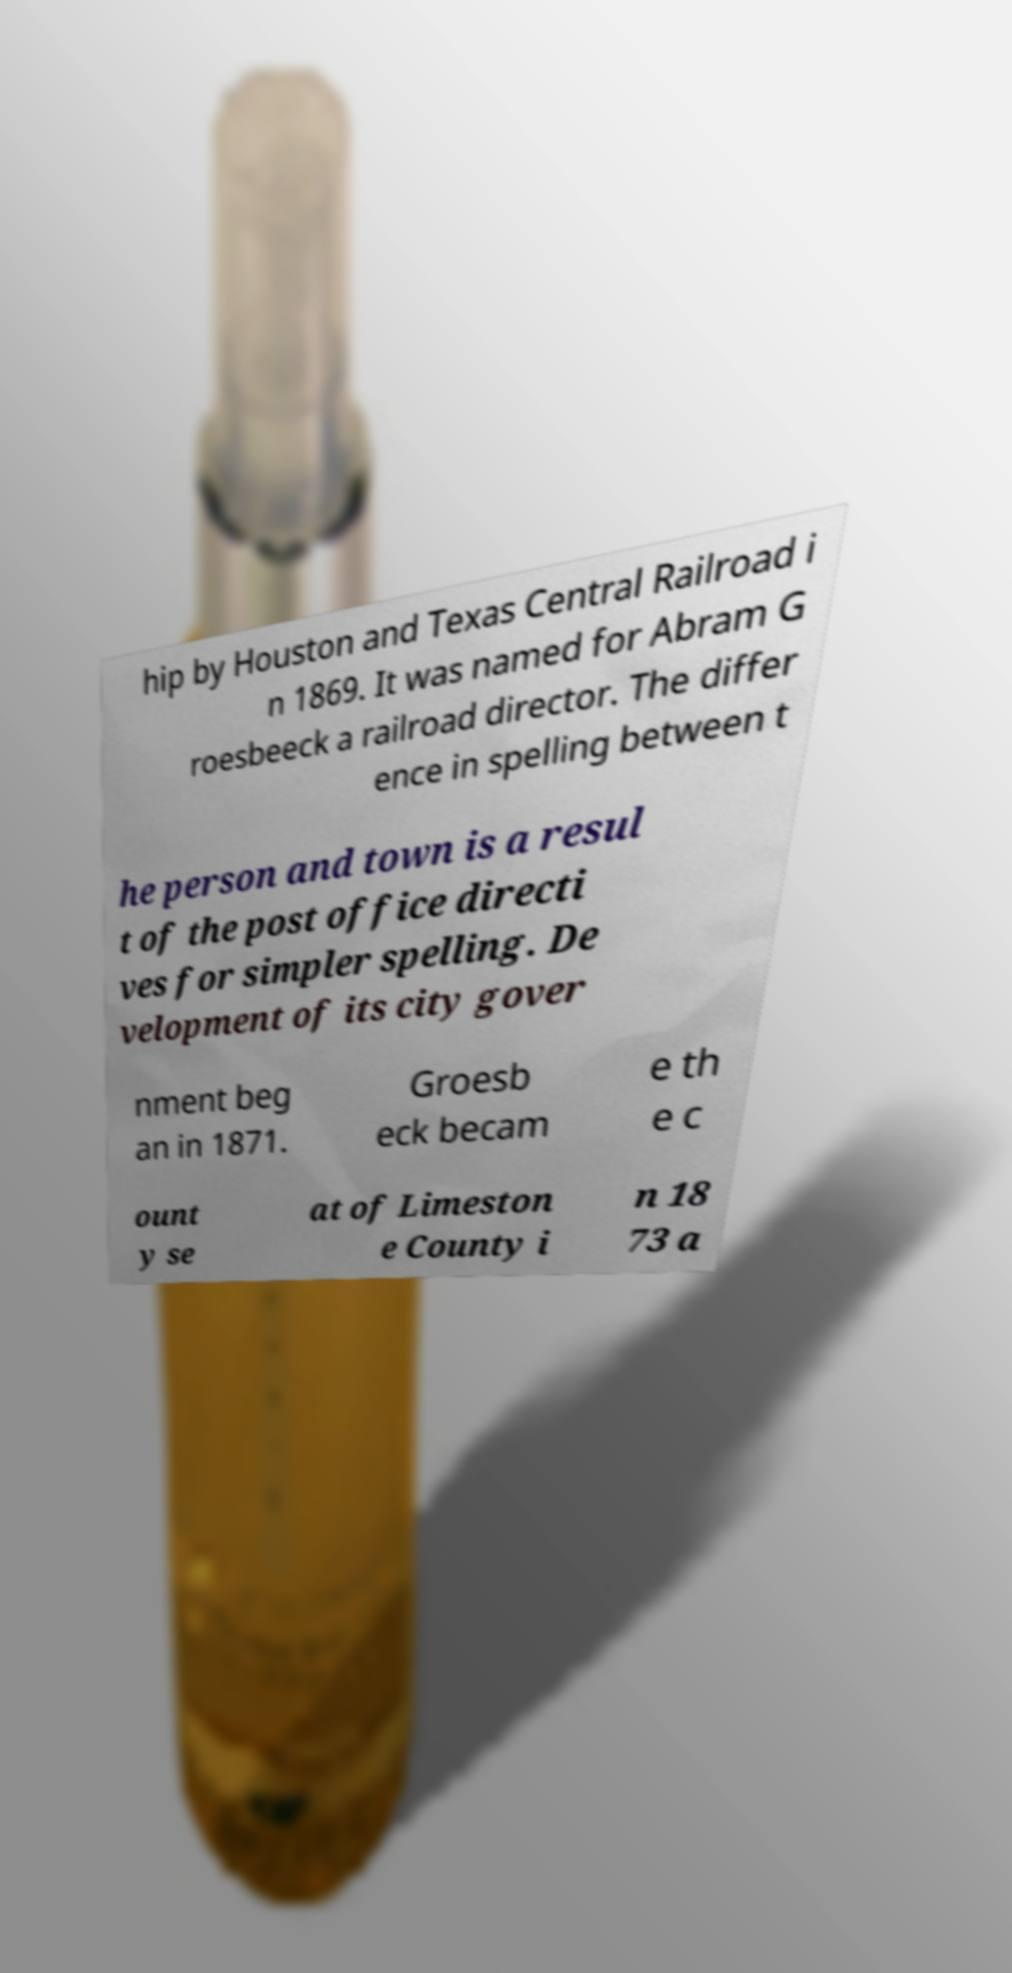Could you extract and type out the text from this image? hip by Houston and Texas Central Railroad i n 1869. It was named for Abram G roesbeeck a railroad director. The differ ence in spelling between t he person and town is a resul t of the post office directi ves for simpler spelling. De velopment of its city gover nment beg an in 1871. Groesb eck becam e th e c ount y se at of Limeston e County i n 18 73 a 